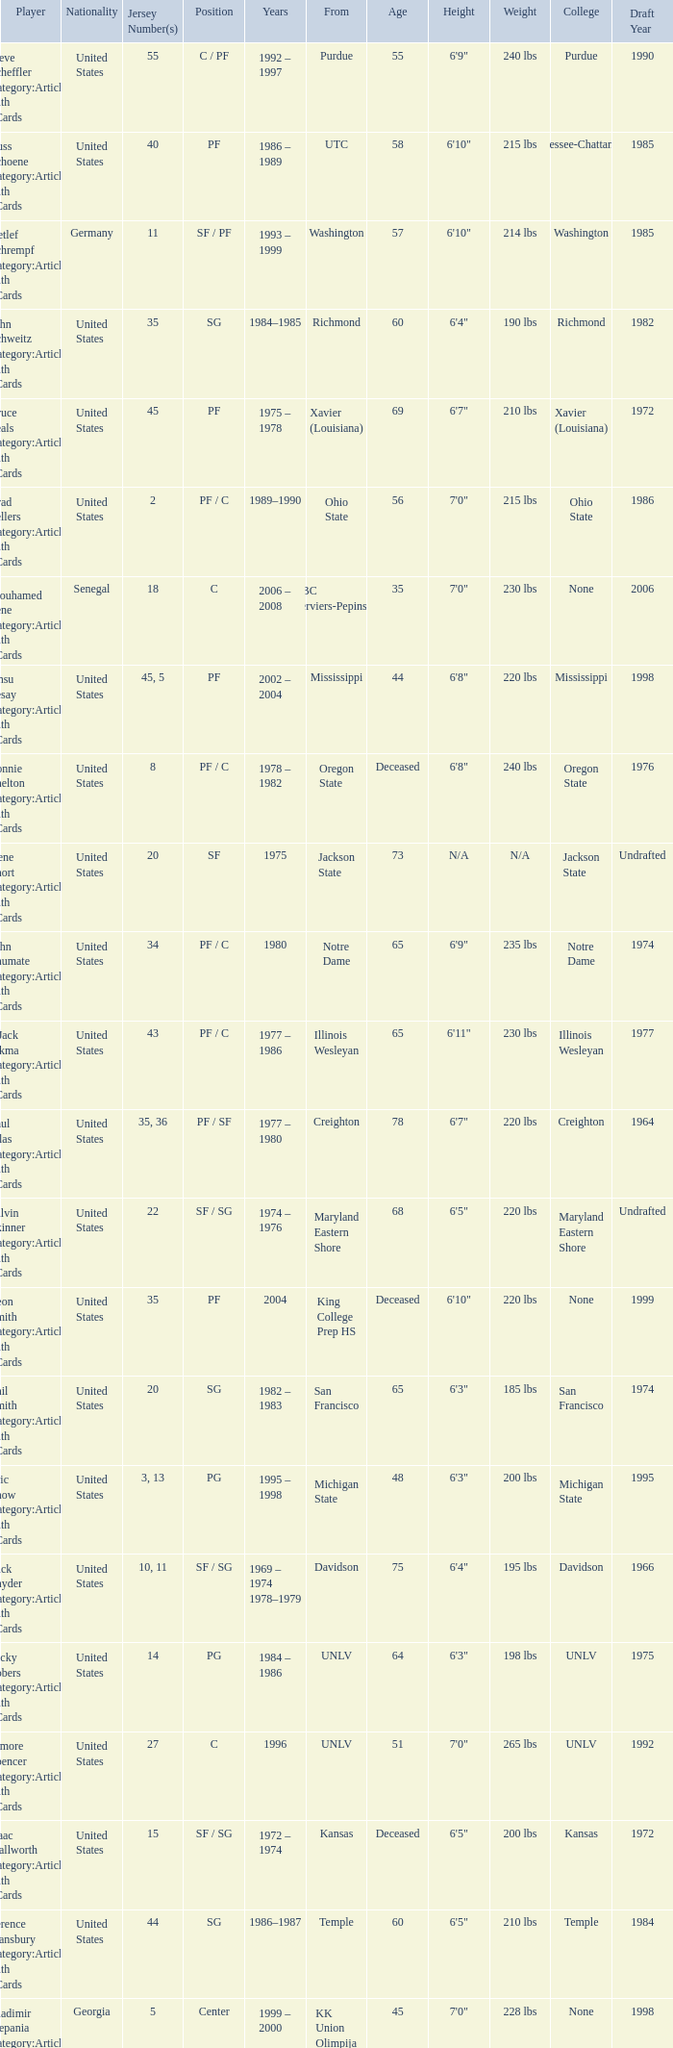What position does the player with jersey number 22 play? SF / SG. Parse the full table. {'header': ['Player', 'Nationality', 'Jersey Number(s)', 'Position', 'Years', 'From', 'Age', 'Height', 'Weight', 'College', 'Draft Year'], 'rows': [['Steve Scheffler Category:Articles with hCards', 'United States', '55', 'C / PF', '1992 – 1997', 'Purdue', '55', '6\'9"', '240 lbs', 'Purdue', '1990'], ['Russ Schoene Category:Articles with hCards', 'United States', '40', 'PF', '1986 – 1989', 'UTC', '58', '6\'10"', '215 lbs', 'Tennessee-Chattanooga', '1985'], ['Detlef Schrempf Category:Articles with hCards', 'Germany', '11', 'SF / PF', '1993 – 1999', 'Washington', '57', '6\'10"', '214 lbs', 'Washington', '1985'], ['John Schweitz Category:Articles with hCards', 'United States', '35', 'SG', '1984–1985', 'Richmond', '60', '6\'4"', '190 lbs', 'Richmond', '1982'], ['Bruce Seals Category:Articles with hCards', 'United States', '45', 'PF', '1975 – 1978', 'Xavier (Louisiana)', '69', '6\'7"', '210 lbs', 'Xavier (Louisiana)', '1972'], ['Brad Sellers Category:Articles with hCards', 'United States', '2', 'PF / C', '1989–1990', 'Ohio State', '56', '7\'0"', '215 lbs', 'Ohio State', '1986'], ['Mouhamed Sene Category:Articles with hCards', 'Senegal', '18', 'C', '2006 – 2008', 'RBC Verviers-Pepinster', '35', '7\'0"', '230 lbs', 'None', '2006'], ['Ansu Sesay Category:Articles with hCards', 'United States', '45, 5', 'PF', '2002 – 2004', 'Mississippi', '44', '6\'8"', '220 lbs', 'Mississippi', '1998'], ['Lonnie Shelton Category:Articles with hCards', 'United States', '8', 'PF / C', '1978 – 1982', 'Oregon State', 'Deceased', '6\'8"', '240 lbs', 'Oregon State', '1976'], ['Gene Short Category:Articles with hCards', 'United States', '20', 'SF', '1975', 'Jackson State', '73', 'N/A', 'N/A', 'Jackson State', 'Undrafted'], ['John Shumate Category:Articles with hCards', 'United States', '34', 'PF / C', '1980', 'Notre Dame', '65', '6\'9"', '235 lbs', 'Notre Dame', '1974'], ['^ Jack Sikma Category:Articles with hCards', 'United States', '43', 'PF / C', '1977 – 1986', 'Illinois Wesleyan', '65', '6\'11"', '230 lbs', 'Illinois Wesleyan', '1977'], ['Paul Silas Category:Articles with hCards', 'United States', '35, 36', 'PF / SF', '1977 – 1980', 'Creighton', '78', '6\'7"', '220 lbs', 'Creighton', '1964'], ['Talvin Skinner Category:Articles with hCards', 'United States', '22', 'SF / SG', '1974 – 1976', 'Maryland Eastern Shore', '68', '6\'5"', '220 lbs', 'Maryland Eastern Shore', 'Undrafted'], ['Leon Smith Category:Articles with hCards', 'United States', '35', 'PF', '2004', 'King College Prep HS', 'Deceased', '6\'10"', '220 lbs', 'None', '1999'], ['Phil Smith Category:Articles with hCards', 'United States', '20', 'SG', '1982 – 1983', 'San Francisco', '65', '6\'3"', '185 lbs', 'San Francisco', '1974'], ['Eric Snow Category:Articles with hCards', 'United States', '3, 13', 'PG', '1995 – 1998', 'Michigan State', '48', '6\'3"', '200 lbs', 'Michigan State', '1995'], ['Dick Snyder Category:Articles with hCards', 'United States', '10, 11', 'SF / SG', '1969 – 1974 1978–1979', 'Davidson', '75', '6\'4"', '195 lbs', 'Davidson', '1966'], ['Ricky Sobers Category:Articles with hCards', 'United States', '14', 'PG', '1984 – 1986', 'UNLV', '64', '6\'3"', '198 lbs', 'UNLV', '1975'], ['Elmore Spencer Category:Articles with hCards', 'United States', '27', 'C', '1996', 'UNLV', '51', '7\'0"', '265 lbs', 'UNLV', '1992'], ['Isaac Stallworth Category:Articles with hCards', 'United States', '15', 'SF / SG', '1972 – 1974', 'Kansas', 'Deceased', '6\'5"', '200 lbs', 'Kansas', '1972'], ['Terence Stansbury Category:Articles with hCards', 'United States', '44', 'SG', '1986–1987', 'Temple', '60', '6\'5"', '210 lbs', 'Temple', '1984'], ['Vladimir Stepania Category:Articles with hCards', 'Georgia', '5', 'Center', '1999 – 2000', 'KK Union Olimpija', '45', '7\'0"', '228 lbs', 'None', '1998'], ['Larry Stewart Category:Articles with hCards', 'United States', '23', 'SF', '1996–1997', 'Coppin State', '50', '6\'8"', '220 lbs', 'Coppin State', 'Undrafted'], ['Alex Stivrins Category:Articles with hCards', 'United States', '42', 'PF', '1985', 'Colorado', '58', '6\'9"', '225 lbs', 'Colorado', '1985'], ['Jon Sundvold Category:Articles with hCards', 'United States', '20', 'SG', '1984 – 1985', 'Missouri', '60', '6\'2"', '170 lbs', 'Missouri', '1983'], ['Robert Swift Category:Articles with hCards', 'United States', '31', 'C', '2005 – 2008', 'Bakersfield HS', '35', '7\'1"', '270 lbs', 'None', '2004'], ['Wally Szczerbiak Category:Articles with hCards', 'United States', '3', 'SF / SG', '2007–2008', 'Miami (Ohio)', '44', '6\'7"', '245 lbs', 'Miami (Ohio)', '1999']]} 